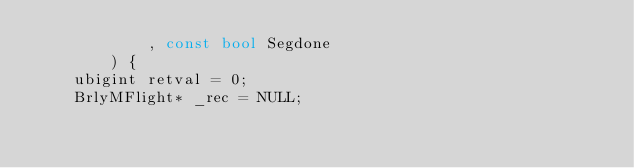<code> <loc_0><loc_0><loc_500><loc_500><_C++_>			, const bool Segdone
		) {
	ubigint retval = 0;
	BrlyMFlight* _rec = NULL;
</code> 